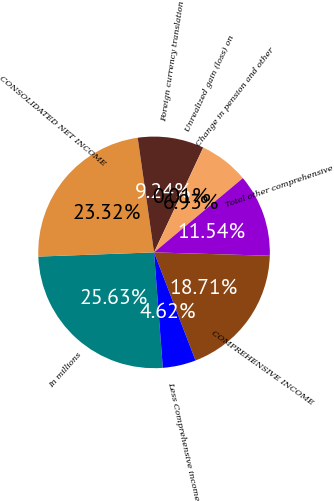Convert chart. <chart><loc_0><loc_0><loc_500><loc_500><pie_chart><fcel>In millions<fcel>CONSOLIDATED NET INCOME<fcel>Foreign currency translation<fcel>Unrealized gain (loss) on<fcel>Change in pension and other<fcel>Total other comprehensive<fcel>COMPREHENSIVE INCOME<fcel>Less Comprehensive income<nl><fcel>25.63%<fcel>23.32%<fcel>9.24%<fcel>0.01%<fcel>6.93%<fcel>11.54%<fcel>18.71%<fcel>4.62%<nl></chart> 